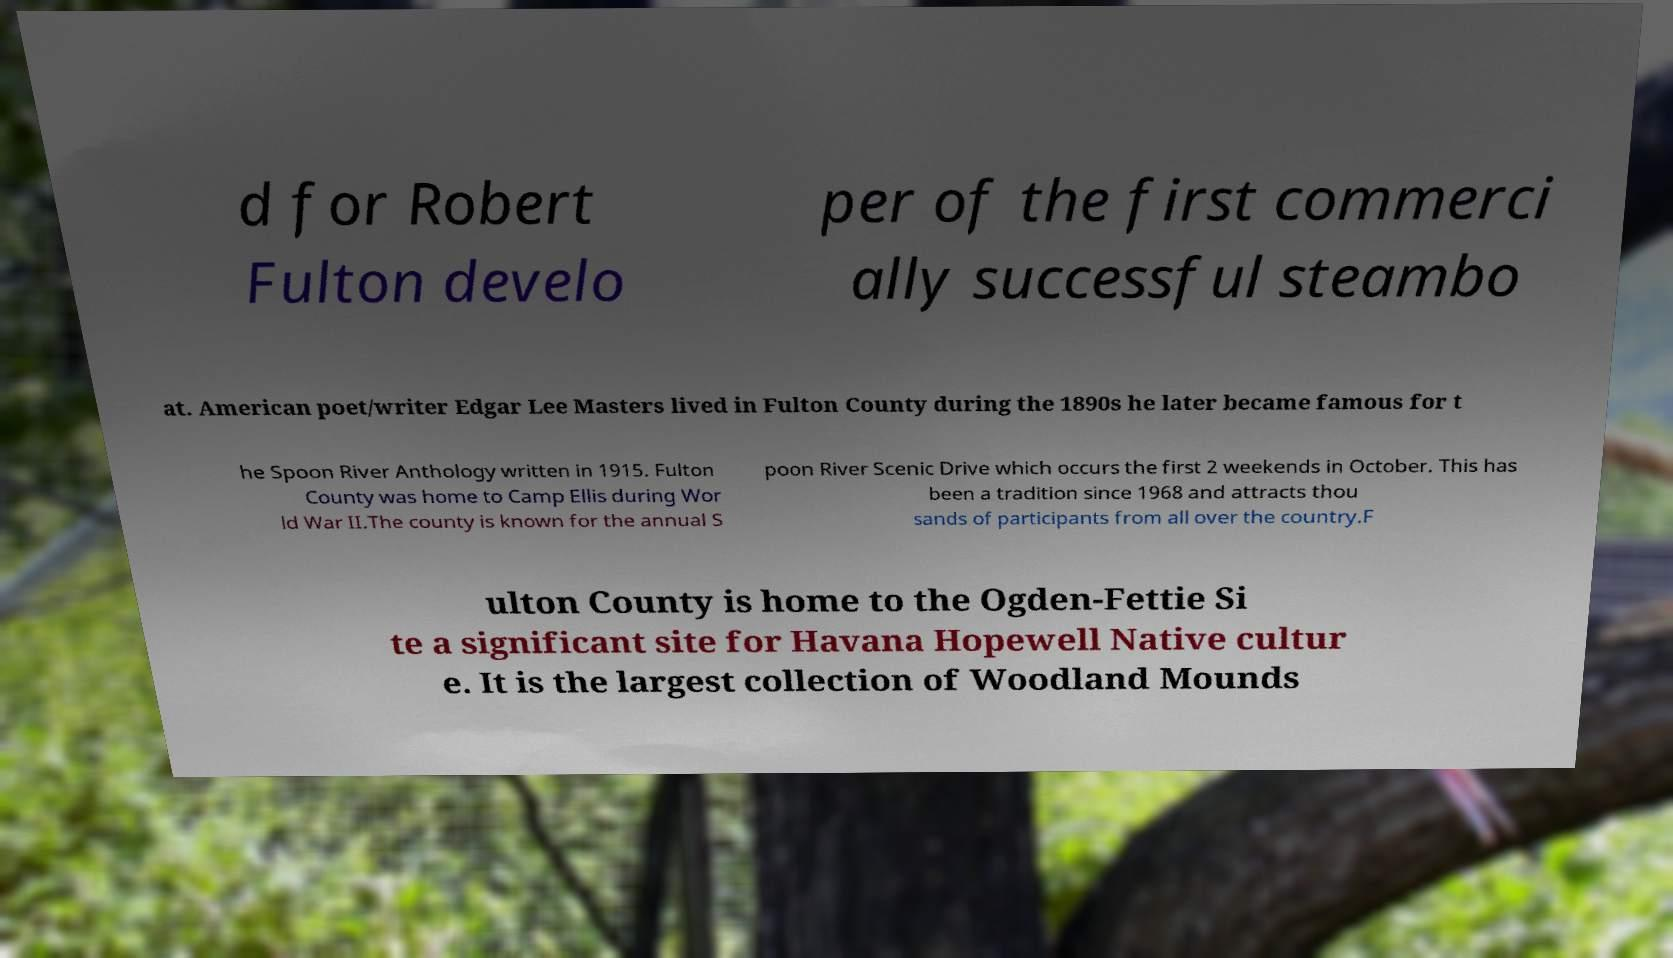Can you accurately transcribe the text from the provided image for me? d for Robert Fulton develo per of the first commerci ally successful steambo at. American poet/writer Edgar Lee Masters lived in Fulton County during the 1890s he later became famous for t he Spoon River Anthology written in 1915. Fulton County was home to Camp Ellis during Wor ld War II.The county is known for the annual S poon River Scenic Drive which occurs the first 2 weekends in October. This has been a tradition since 1968 and attracts thou sands of participants from all over the country.F ulton County is home to the Ogden-Fettie Si te a significant site for Havana Hopewell Native cultur e. It is the largest collection of Woodland Mounds 